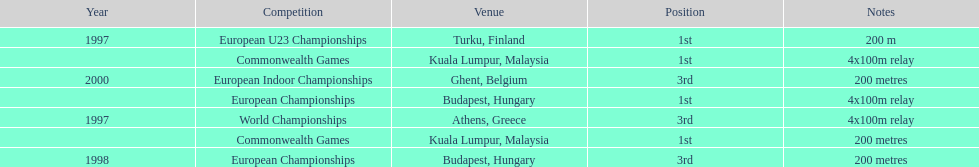How many total years did golding compete? 3. 